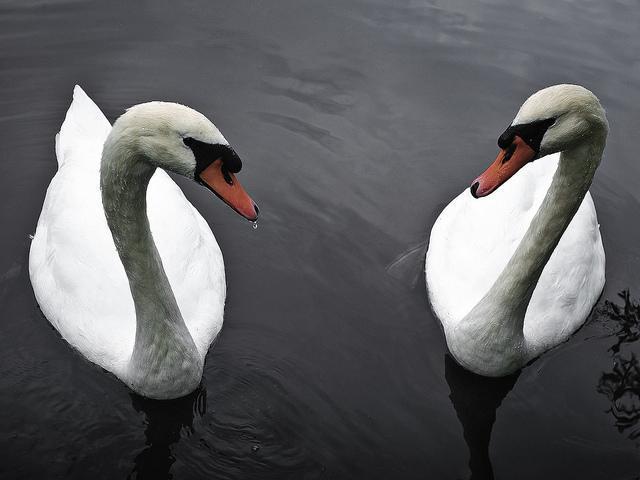How many birds?
Give a very brief answer. 2. How many birds are there?
Give a very brief answer. 2. How many chairs are facing the far wall?
Give a very brief answer. 0. 